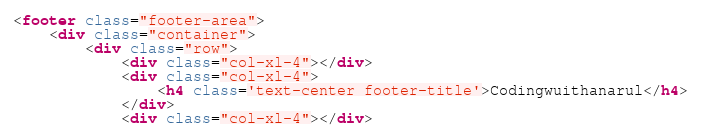<code> <loc_0><loc_0><loc_500><loc_500><_HTML_><footer class="footer-area">
    <div class="container">
        <div class="row">
            <div class="col-xl-4"></div>
            <div class="col-xl-4">
                <h4 class='text-center footer-title'>Codingwuithanarul</h4>
            </div>
            <div class="col-xl-4"></div></code> 